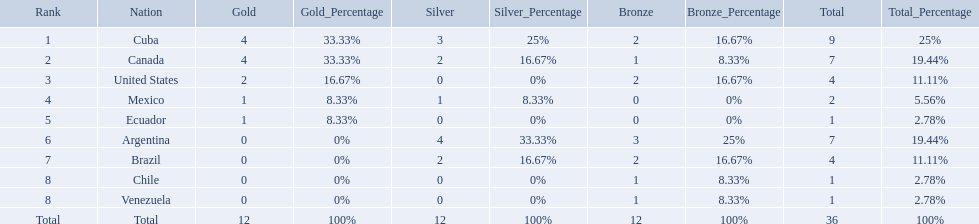Which nations competed in the 2011 pan american games? Cuba, Canada, United States, Mexico, Ecuador, Argentina, Brazil, Chile, Venezuela. Of these nations which ones won gold? Cuba, Canada, United States, Mexico, Ecuador. Which nation of the ones that won gold did not win silver? United States. What were all of the nations involved in the canoeing at the 2011 pan american games? Cuba, Canada, United States, Mexico, Ecuador, Argentina, Brazil, Chile, Venezuela, Total. Of these, which had a numbered rank? Cuba, Canada, United States, Mexico, Ecuador, Argentina, Brazil, Chile, Venezuela. From these, which had the highest number of bronze? Argentina. 